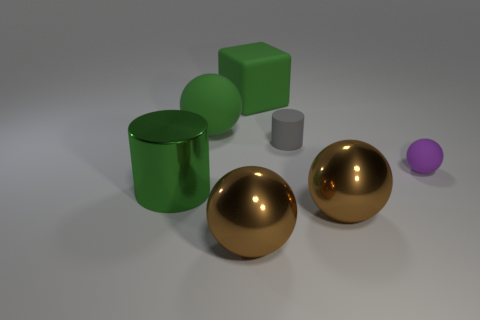Subtract all purple cylinders. How many brown spheres are left? 2 Subtract all small purple balls. How many balls are left? 3 Add 2 tiny purple shiny cylinders. How many objects exist? 9 Subtract all purple balls. How many balls are left? 3 Subtract 0 purple cubes. How many objects are left? 7 Subtract all cubes. How many objects are left? 6 Subtract all purple blocks. Subtract all green cylinders. How many blocks are left? 1 Subtract all tiny blue metal cylinders. Subtract all big green things. How many objects are left? 4 Add 3 tiny purple rubber objects. How many tiny purple rubber objects are left? 4 Add 4 small cyan matte blocks. How many small cyan matte blocks exist? 4 